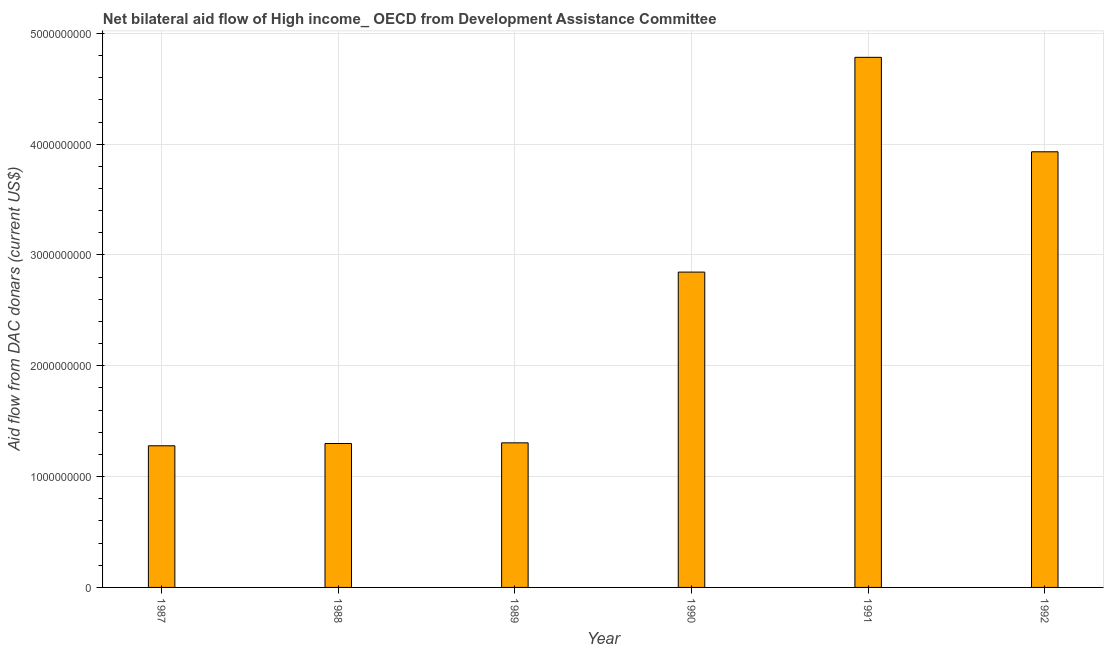Does the graph contain any zero values?
Offer a terse response. No. Does the graph contain grids?
Provide a short and direct response. Yes. What is the title of the graph?
Provide a succinct answer. Net bilateral aid flow of High income_ OECD from Development Assistance Committee. What is the label or title of the Y-axis?
Provide a short and direct response. Aid flow from DAC donars (current US$). What is the net bilateral aid flows from dac donors in 1989?
Provide a short and direct response. 1.30e+09. Across all years, what is the maximum net bilateral aid flows from dac donors?
Provide a succinct answer. 4.78e+09. Across all years, what is the minimum net bilateral aid flows from dac donors?
Provide a short and direct response. 1.28e+09. In which year was the net bilateral aid flows from dac donors maximum?
Give a very brief answer. 1991. In which year was the net bilateral aid flows from dac donors minimum?
Keep it short and to the point. 1987. What is the sum of the net bilateral aid flows from dac donors?
Give a very brief answer. 1.54e+1. What is the difference between the net bilateral aid flows from dac donors in 1988 and 1991?
Ensure brevity in your answer.  -3.48e+09. What is the average net bilateral aid flows from dac donors per year?
Your answer should be very brief. 2.57e+09. What is the median net bilateral aid flows from dac donors?
Give a very brief answer. 2.08e+09. Do a majority of the years between 1988 and 1989 (inclusive) have net bilateral aid flows from dac donors greater than 3800000000 US$?
Keep it short and to the point. No. What is the ratio of the net bilateral aid flows from dac donors in 1989 to that in 1990?
Provide a succinct answer. 0.46. Is the difference between the net bilateral aid flows from dac donors in 1987 and 1992 greater than the difference between any two years?
Your answer should be very brief. No. What is the difference between the highest and the second highest net bilateral aid flows from dac donors?
Offer a terse response. 8.52e+08. Is the sum of the net bilateral aid flows from dac donors in 1991 and 1992 greater than the maximum net bilateral aid flows from dac donors across all years?
Your answer should be very brief. Yes. What is the difference between the highest and the lowest net bilateral aid flows from dac donors?
Offer a terse response. 3.51e+09. In how many years, is the net bilateral aid flows from dac donors greater than the average net bilateral aid flows from dac donors taken over all years?
Your answer should be compact. 3. How many bars are there?
Your answer should be compact. 6. How many years are there in the graph?
Keep it short and to the point. 6. What is the difference between two consecutive major ticks on the Y-axis?
Your response must be concise. 1.00e+09. What is the Aid flow from DAC donars (current US$) in 1987?
Your answer should be compact. 1.28e+09. What is the Aid flow from DAC donars (current US$) in 1988?
Offer a terse response. 1.30e+09. What is the Aid flow from DAC donars (current US$) in 1989?
Make the answer very short. 1.30e+09. What is the Aid flow from DAC donars (current US$) of 1990?
Ensure brevity in your answer.  2.85e+09. What is the Aid flow from DAC donars (current US$) in 1991?
Offer a terse response. 4.78e+09. What is the Aid flow from DAC donars (current US$) of 1992?
Make the answer very short. 3.93e+09. What is the difference between the Aid flow from DAC donars (current US$) in 1987 and 1988?
Give a very brief answer. -2.07e+07. What is the difference between the Aid flow from DAC donars (current US$) in 1987 and 1989?
Make the answer very short. -2.66e+07. What is the difference between the Aid flow from DAC donars (current US$) in 1987 and 1990?
Provide a short and direct response. -1.57e+09. What is the difference between the Aid flow from DAC donars (current US$) in 1987 and 1991?
Make the answer very short. -3.51e+09. What is the difference between the Aid flow from DAC donars (current US$) in 1987 and 1992?
Offer a terse response. -2.65e+09. What is the difference between the Aid flow from DAC donars (current US$) in 1988 and 1989?
Offer a very short reply. -5.96e+06. What is the difference between the Aid flow from DAC donars (current US$) in 1988 and 1990?
Make the answer very short. -1.55e+09. What is the difference between the Aid flow from DAC donars (current US$) in 1988 and 1991?
Your response must be concise. -3.48e+09. What is the difference between the Aid flow from DAC donars (current US$) in 1988 and 1992?
Provide a short and direct response. -2.63e+09. What is the difference between the Aid flow from DAC donars (current US$) in 1989 and 1990?
Make the answer very short. -1.54e+09. What is the difference between the Aid flow from DAC donars (current US$) in 1989 and 1991?
Ensure brevity in your answer.  -3.48e+09. What is the difference between the Aid flow from DAC donars (current US$) in 1989 and 1992?
Your answer should be compact. -2.63e+09. What is the difference between the Aid flow from DAC donars (current US$) in 1990 and 1991?
Keep it short and to the point. -1.94e+09. What is the difference between the Aid flow from DAC donars (current US$) in 1990 and 1992?
Keep it short and to the point. -1.09e+09. What is the difference between the Aid flow from DAC donars (current US$) in 1991 and 1992?
Your answer should be very brief. 8.52e+08. What is the ratio of the Aid flow from DAC donars (current US$) in 1987 to that in 1990?
Your response must be concise. 0.45. What is the ratio of the Aid flow from DAC donars (current US$) in 1987 to that in 1991?
Give a very brief answer. 0.27. What is the ratio of the Aid flow from DAC donars (current US$) in 1987 to that in 1992?
Your response must be concise. 0.33. What is the ratio of the Aid flow from DAC donars (current US$) in 1988 to that in 1990?
Make the answer very short. 0.46. What is the ratio of the Aid flow from DAC donars (current US$) in 1988 to that in 1991?
Ensure brevity in your answer.  0.27. What is the ratio of the Aid flow from DAC donars (current US$) in 1988 to that in 1992?
Provide a short and direct response. 0.33. What is the ratio of the Aid flow from DAC donars (current US$) in 1989 to that in 1990?
Ensure brevity in your answer.  0.46. What is the ratio of the Aid flow from DAC donars (current US$) in 1989 to that in 1991?
Make the answer very short. 0.27. What is the ratio of the Aid flow from DAC donars (current US$) in 1989 to that in 1992?
Provide a short and direct response. 0.33. What is the ratio of the Aid flow from DAC donars (current US$) in 1990 to that in 1991?
Your answer should be very brief. 0.59. What is the ratio of the Aid flow from DAC donars (current US$) in 1990 to that in 1992?
Offer a very short reply. 0.72. What is the ratio of the Aid flow from DAC donars (current US$) in 1991 to that in 1992?
Offer a terse response. 1.22. 